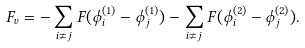Convert formula to latex. <formula><loc_0><loc_0><loc_500><loc_500>F _ { v } = - \sum _ { i \ne j } F ( \phi ^ { ( 1 ) } _ { i } - \phi ^ { ( 1 ) } _ { j } ) - \sum _ { i \ne j } F ( \phi ^ { ( 2 ) } _ { i } - \phi ^ { ( 2 ) } _ { j } ) .</formula> 